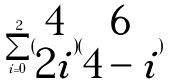<formula> <loc_0><loc_0><loc_500><loc_500>\sum _ { i = 0 } ^ { 2 } ( \begin{matrix} 4 \\ 2 i \end{matrix} ) ( \begin{matrix} 6 \\ 4 - i \end{matrix} )</formula> 